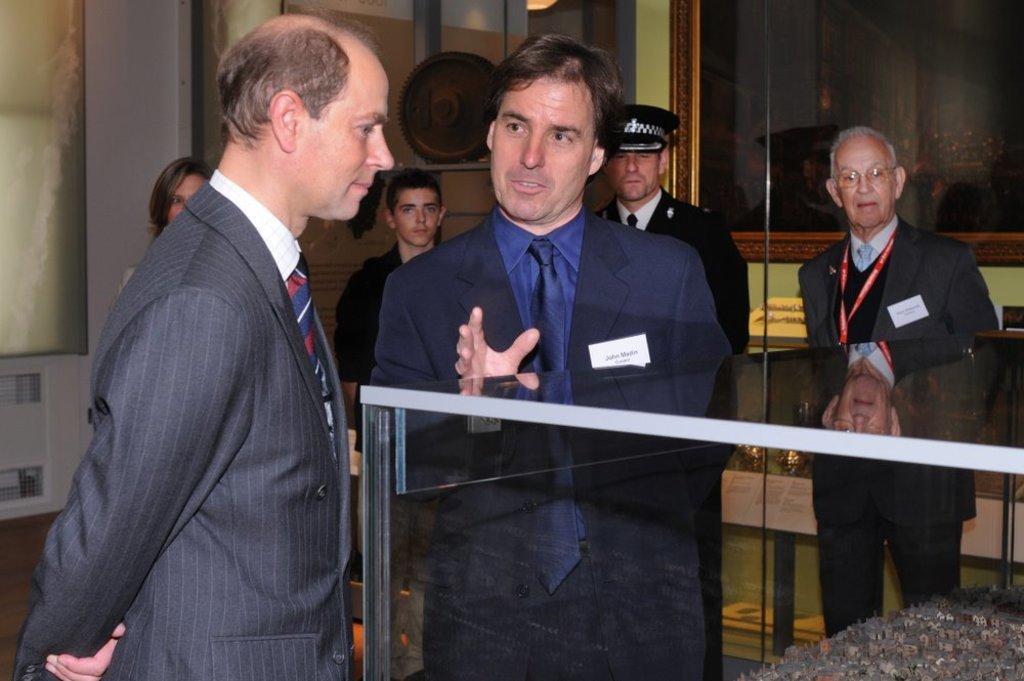Could you give a brief overview of what you see in this image? In the center of the image we can see many persons standing on the floor. In the background we can see persons, photo frame and wall. 